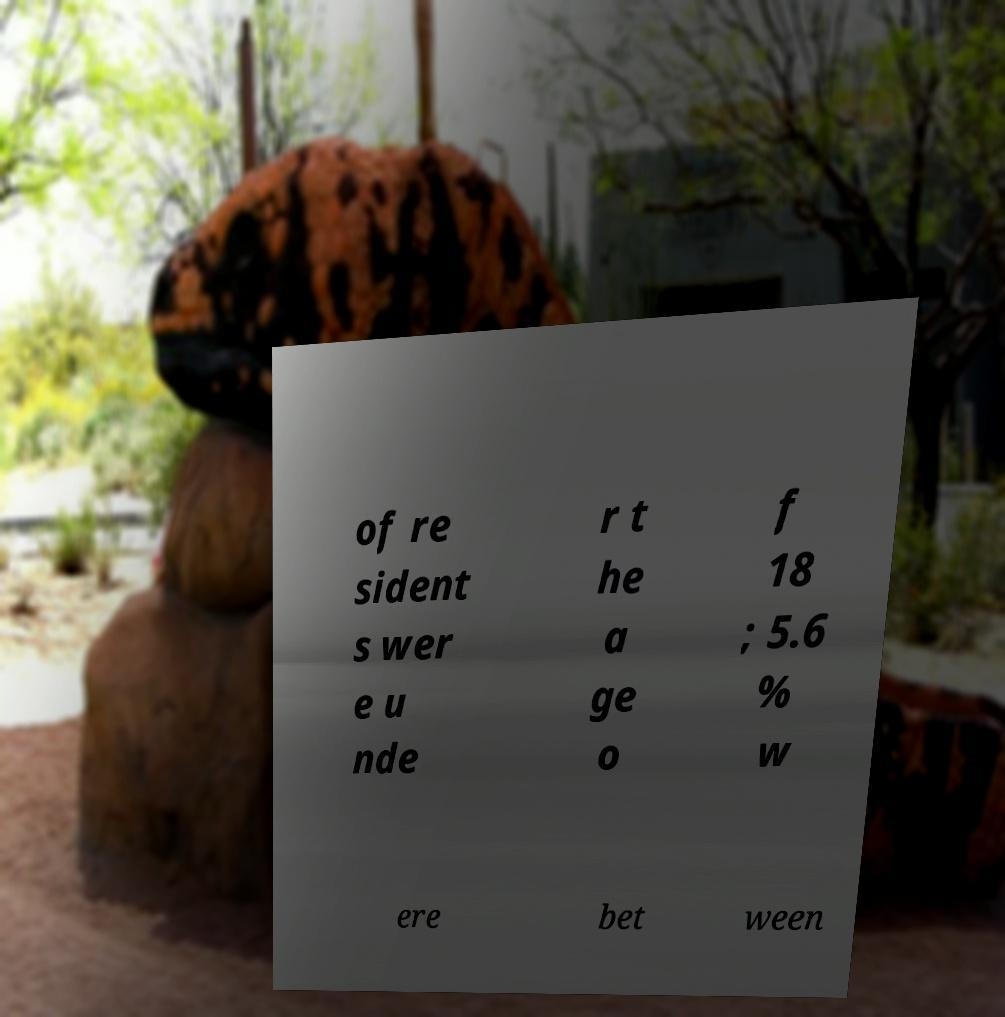Can you accurately transcribe the text from the provided image for me? of re sident s wer e u nde r t he a ge o f 18 ; 5.6 % w ere bet ween 